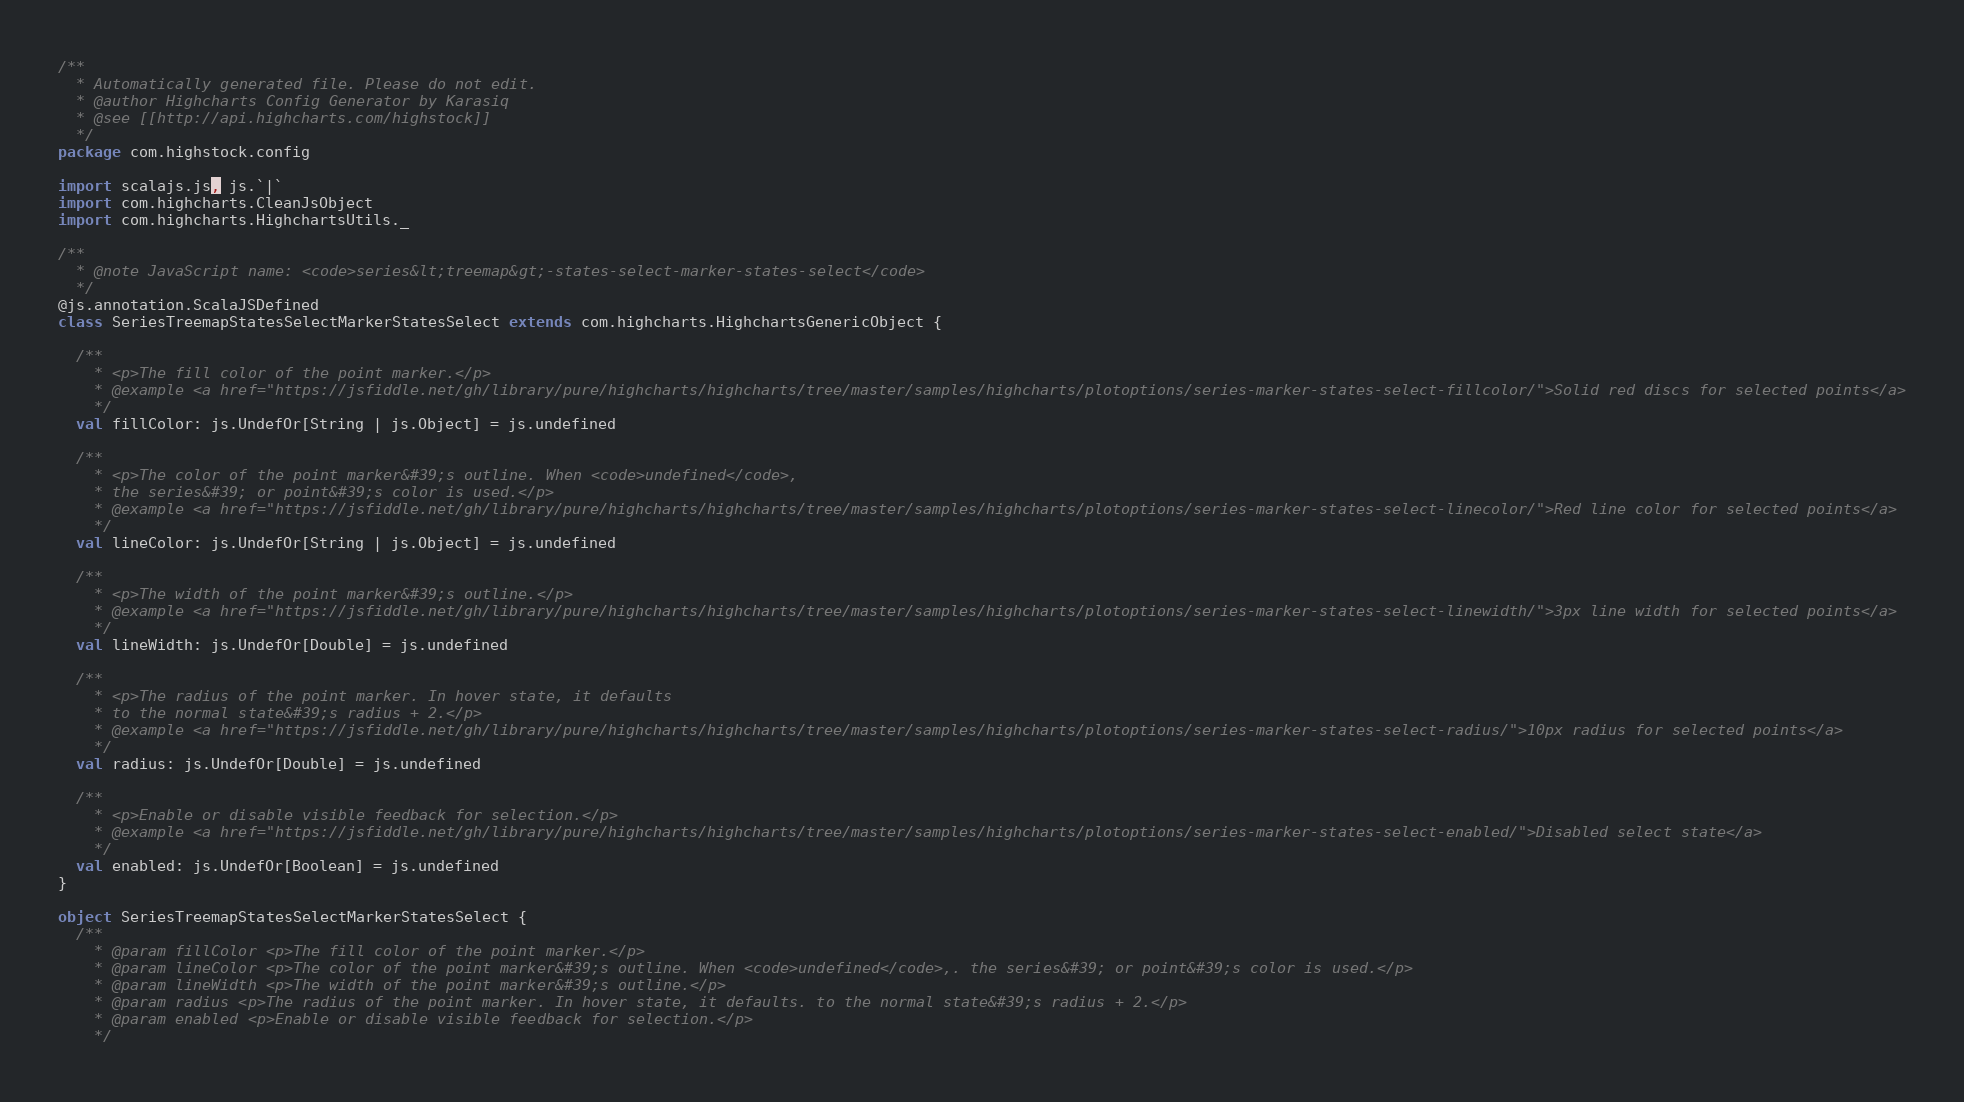Convert code to text. <code><loc_0><loc_0><loc_500><loc_500><_Scala_>/**
  * Automatically generated file. Please do not edit.
  * @author Highcharts Config Generator by Karasiq
  * @see [[http://api.highcharts.com/highstock]]
  */
package com.highstock.config

import scalajs.js, js.`|`
import com.highcharts.CleanJsObject
import com.highcharts.HighchartsUtils._

/**
  * @note JavaScript name: <code>series&lt;treemap&gt;-states-select-marker-states-select</code>
  */
@js.annotation.ScalaJSDefined
class SeriesTreemapStatesSelectMarkerStatesSelect extends com.highcharts.HighchartsGenericObject {

  /**
    * <p>The fill color of the point marker.</p>
    * @example <a href="https://jsfiddle.net/gh/library/pure/highcharts/highcharts/tree/master/samples/highcharts/plotoptions/series-marker-states-select-fillcolor/">Solid red discs for selected points</a>
    */
  val fillColor: js.UndefOr[String | js.Object] = js.undefined

  /**
    * <p>The color of the point marker&#39;s outline. When <code>undefined</code>,
    * the series&#39; or point&#39;s color is used.</p>
    * @example <a href="https://jsfiddle.net/gh/library/pure/highcharts/highcharts/tree/master/samples/highcharts/plotoptions/series-marker-states-select-linecolor/">Red line color for selected points</a>
    */
  val lineColor: js.UndefOr[String | js.Object] = js.undefined

  /**
    * <p>The width of the point marker&#39;s outline.</p>
    * @example <a href="https://jsfiddle.net/gh/library/pure/highcharts/highcharts/tree/master/samples/highcharts/plotoptions/series-marker-states-select-linewidth/">3px line width for selected points</a>
    */
  val lineWidth: js.UndefOr[Double] = js.undefined

  /**
    * <p>The radius of the point marker. In hover state, it defaults
    * to the normal state&#39;s radius + 2.</p>
    * @example <a href="https://jsfiddle.net/gh/library/pure/highcharts/highcharts/tree/master/samples/highcharts/plotoptions/series-marker-states-select-radius/">10px radius for selected points</a>
    */
  val radius: js.UndefOr[Double] = js.undefined

  /**
    * <p>Enable or disable visible feedback for selection.</p>
    * @example <a href="https://jsfiddle.net/gh/library/pure/highcharts/highcharts/tree/master/samples/highcharts/plotoptions/series-marker-states-select-enabled/">Disabled select state</a>
    */
  val enabled: js.UndefOr[Boolean] = js.undefined
}

object SeriesTreemapStatesSelectMarkerStatesSelect {
  /**
    * @param fillColor <p>The fill color of the point marker.</p>
    * @param lineColor <p>The color of the point marker&#39;s outline. When <code>undefined</code>,. the series&#39; or point&#39;s color is used.</p>
    * @param lineWidth <p>The width of the point marker&#39;s outline.</p>
    * @param radius <p>The radius of the point marker. In hover state, it defaults. to the normal state&#39;s radius + 2.</p>
    * @param enabled <p>Enable or disable visible feedback for selection.</p>
    */</code> 